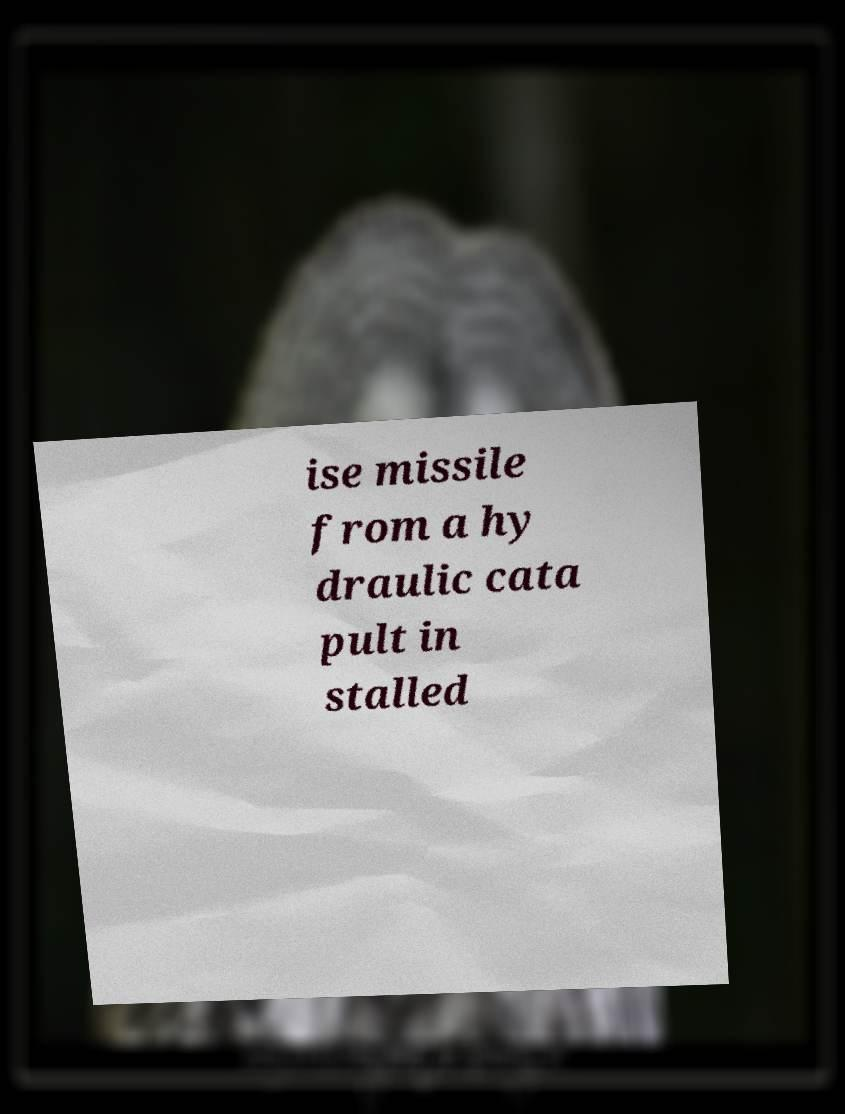Can you read and provide the text displayed in the image?This photo seems to have some interesting text. Can you extract and type it out for me? ise missile from a hy draulic cata pult in stalled 